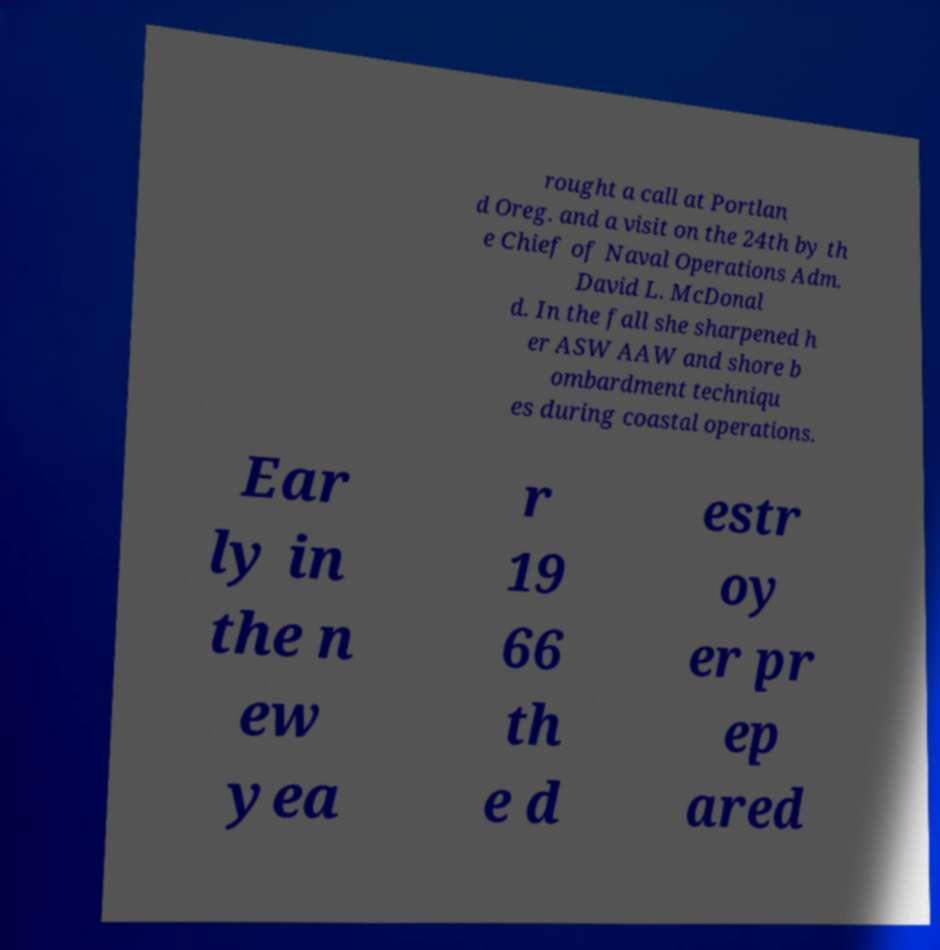Could you extract and type out the text from this image? rought a call at Portlan d Oreg. and a visit on the 24th by th e Chief of Naval Operations Adm. David L. McDonal d. In the fall she sharpened h er ASW AAW and shore b ombardment techniqu es during coastal operations. Ear ly in the n ew yea r 19 66 th e d estr oy er pr ep ared 